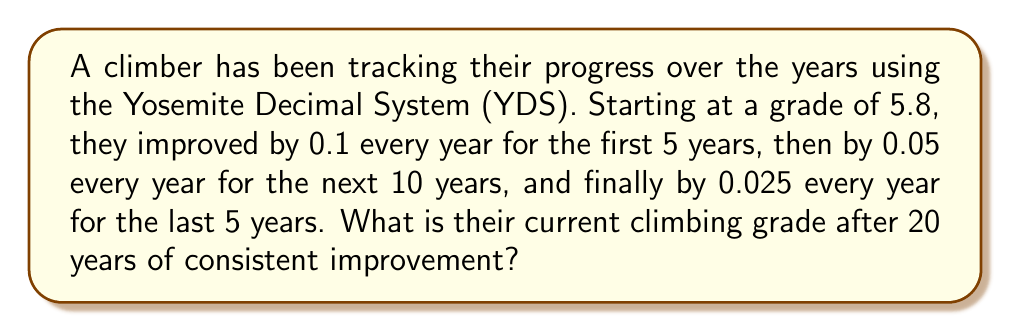Help me with this question. Let's break this down step-by-step:

1. Initial grade: 5.8

2. First 5 years:
   Improvement per year = 0.1
   Total improvement = $5 \times 0.1 = 0.5$
   Grade after 5 years = $5.8 + 0.5 = 6.3$

3. Next 10 years:
   Improvement per year = 0.05
   Total improvement = $10 \times 0.05 = 0.5$
   Grade after 15 years = $6.3 + 0.5 = 6.8$

4. Last 5 years:
   Improvement per year = 0.025
   Total improvement = $5 \times 0.025 = 0.125$
   Final grade = $6.8 + 0.125 = 6.925$

5. The YDS uses integer values after the decimal point, so we round down to the nearest tenth.

Therefore, the final grade after 20 years is 6.9 in the YDS.
Answer: 6.9 